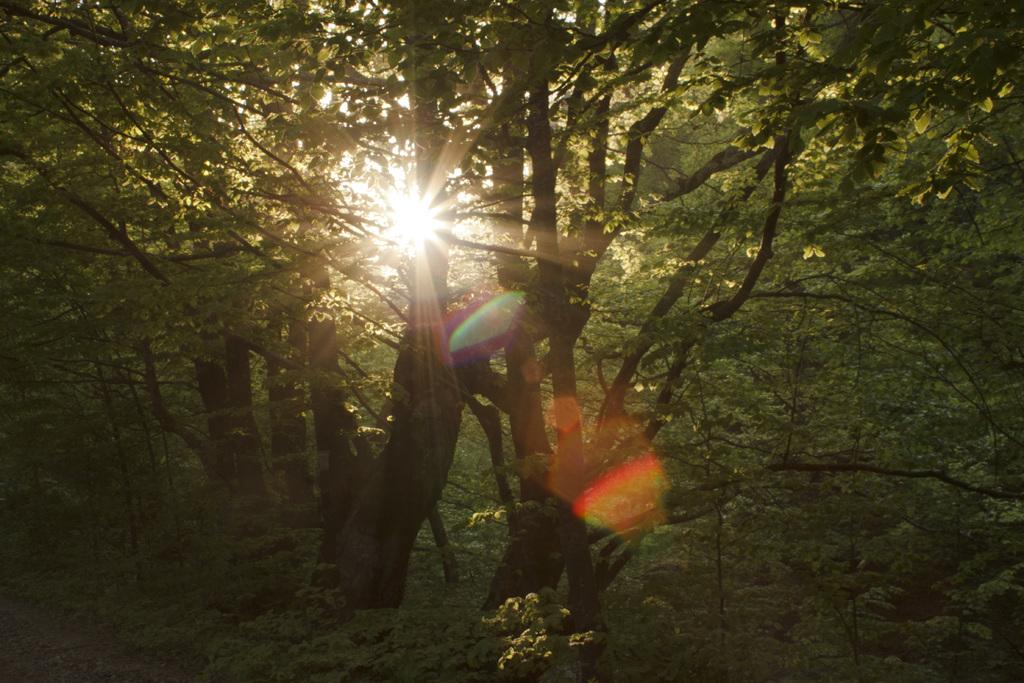What type of vegetation can be seen in the image? There are trees in the image. What celestial body is visible in the center of the image? The sun is shining in the center of the image. What type of toes can be seen in the image? There are no toes visible in the image; it features trees and the sun. What weather condition is depicted in the image? The image does not depict any specific weather condition, as it only shows trees and the sun. 